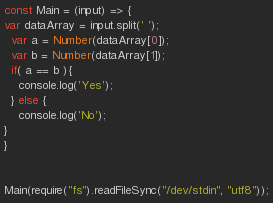<code> <loc_0><loc_0><loc_500><loc_500><_JavaScript_>const Main = (input) => {
var dataArray = input.split(' ');
  var a = Number(dataArray[0]);
  var b = Number(dataArray[1]);
  if( a == b ){
  	console.log('Yes');
  } else {
    console.log('No');
}
}


Main(require("fs").readFileSync("/dev/stdin", "utf8"));</code> 